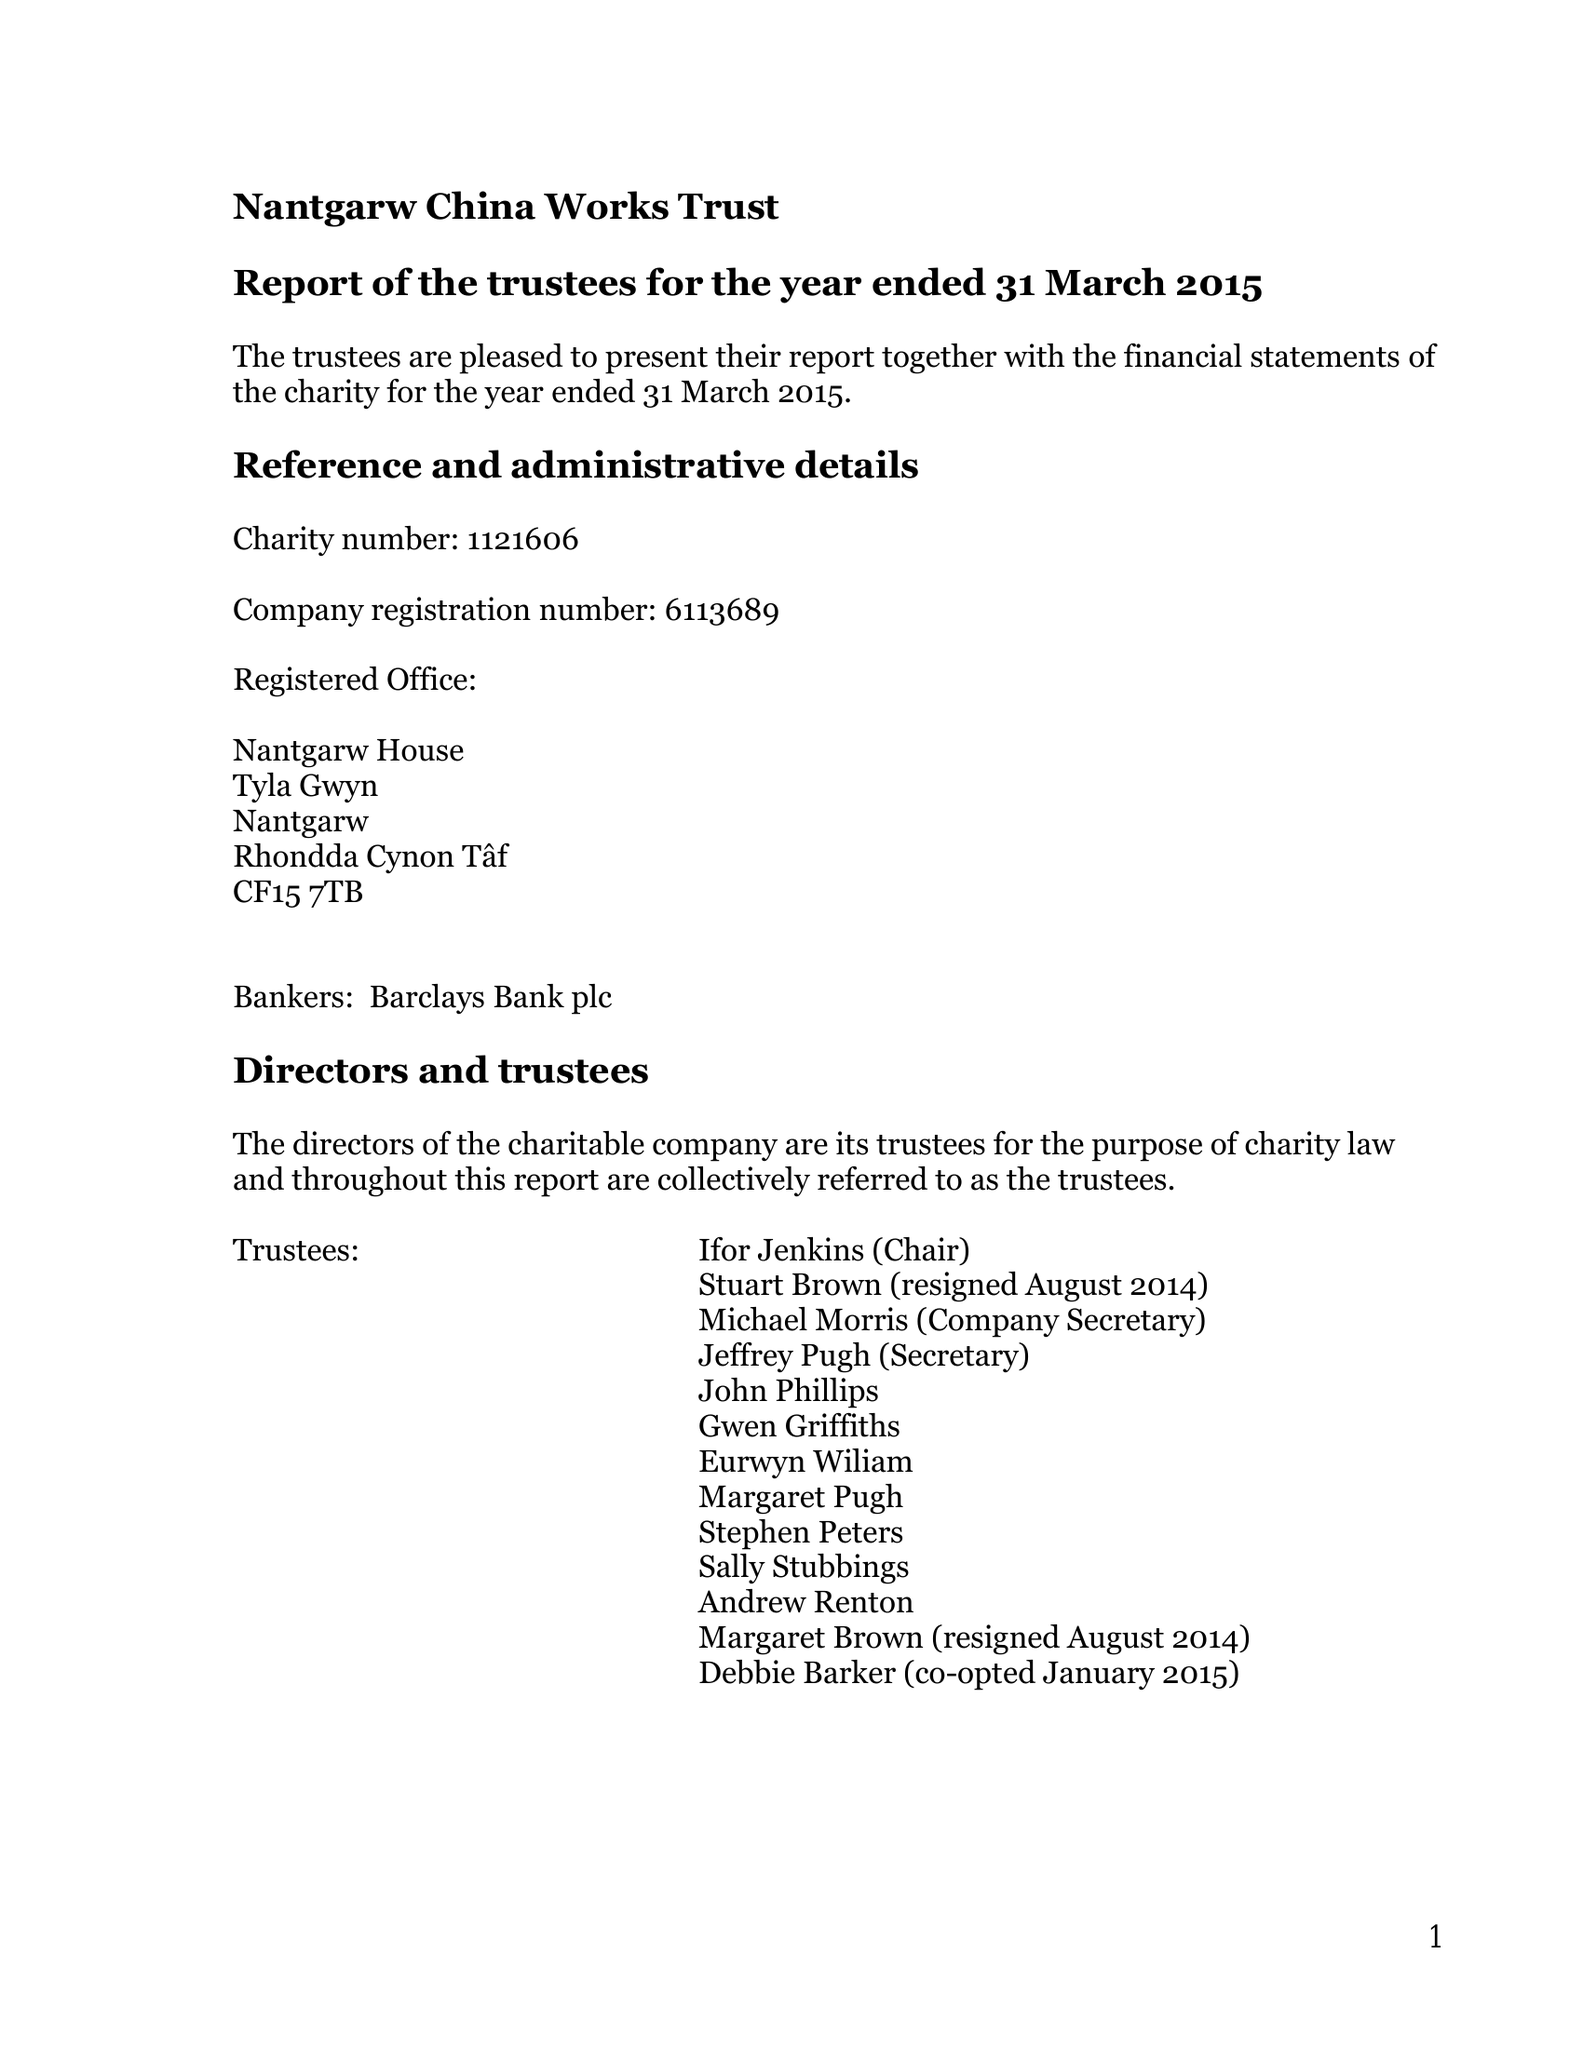What is the value for the address__post_town?
Answer the question using a single word or phrase. CARDIFF 